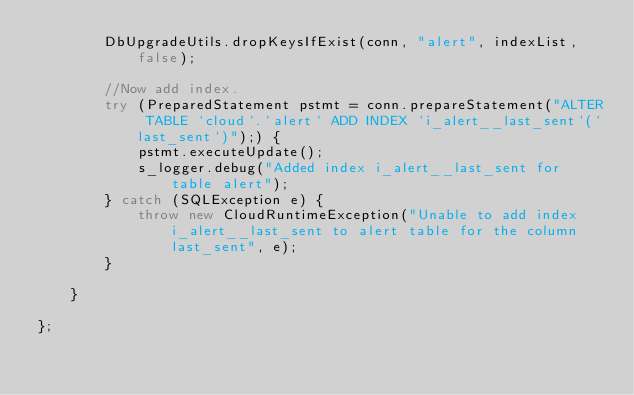<code> <loc_0><loc_0><loc_500><loc_500><_Java_>        DbUpgradeUtils.dropKeysIfExist(conn, "alert", indexList, false);

        //Now add index.
        try (PreparedStatement pstmt = conn.prepareStatement("ALTER TABLE `cloud`.`alert` ADD INDEX `i_alert__last_sent`(`last_sent`)");) {
            pstmt.executeUpdate();
            s_logger.debug("Added index i_alert__last_sent for table alert");
        } catch (SQLException e) {
            throw new CloudRuntimeException("Unable to add index i_alert__last_sent to alert table for the column last_sent", e);
        }

    }

};</code> 